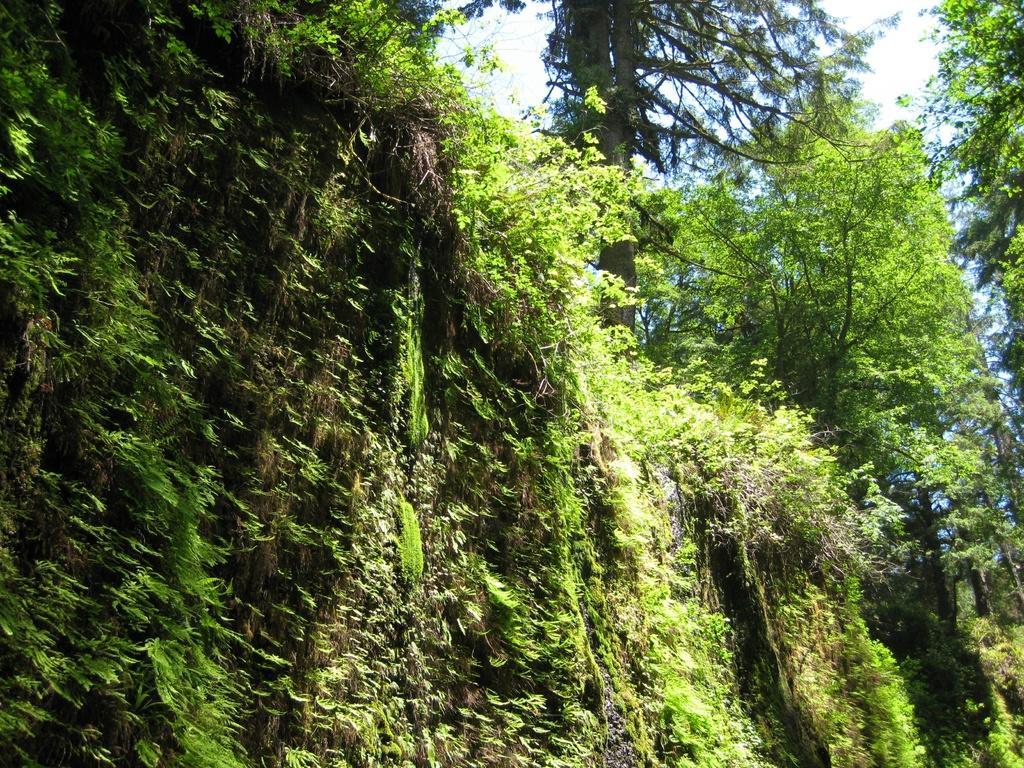In one or two sentences, can you explain what this image depicts? In the image there is a lot of greenery and in the background there is a sky. 